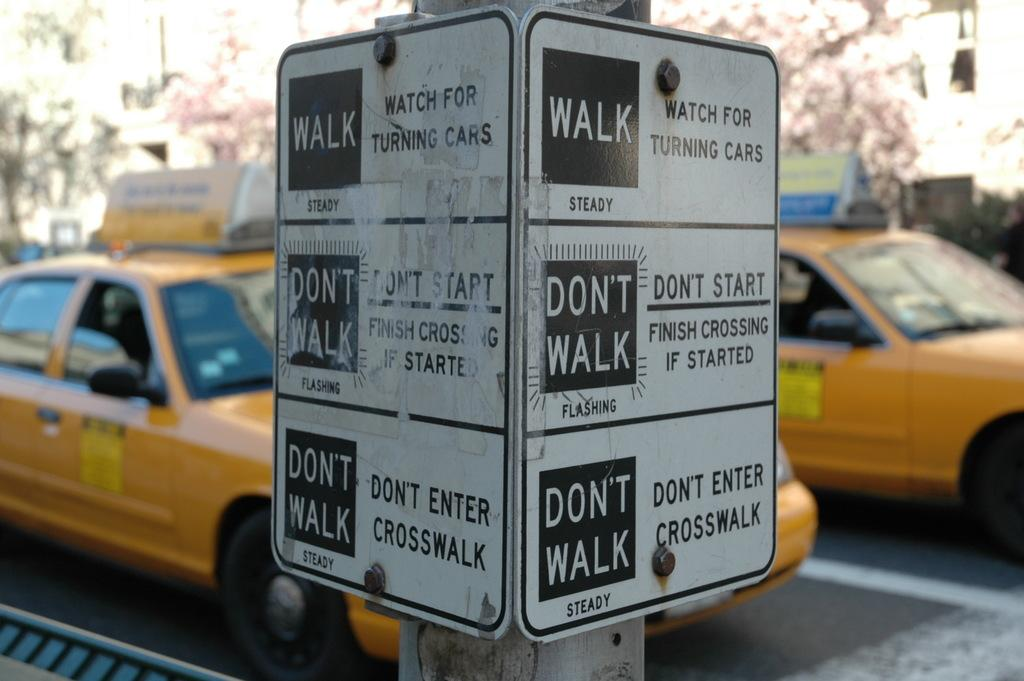Provide a one-sentence caption for the provided image. A sign posted at a coss walk indicating a pedestrian should walk or not walk depending on the sign displayed at if the light is steady or flashing. 